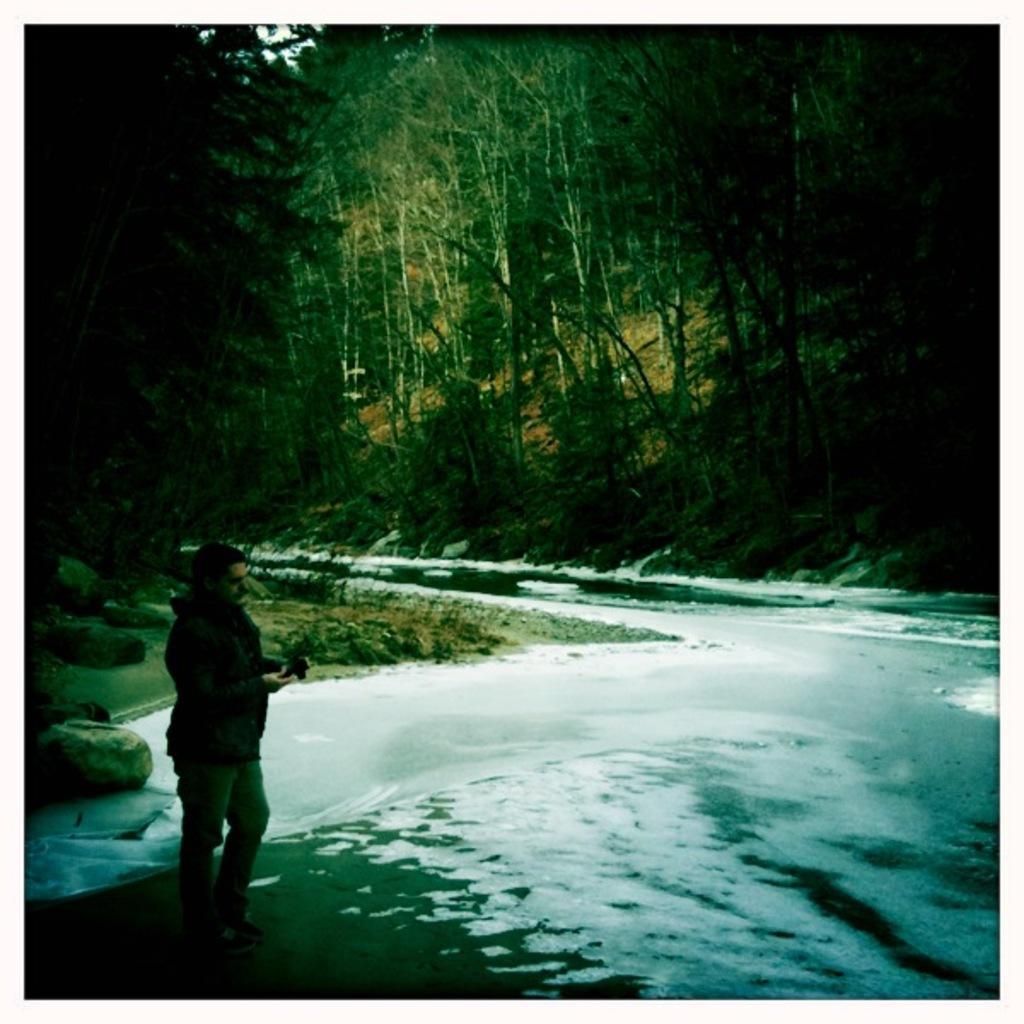Can you describe this image briefly? In the picture we can see a road between the trees and a man standing on the road wearing a jacket. 